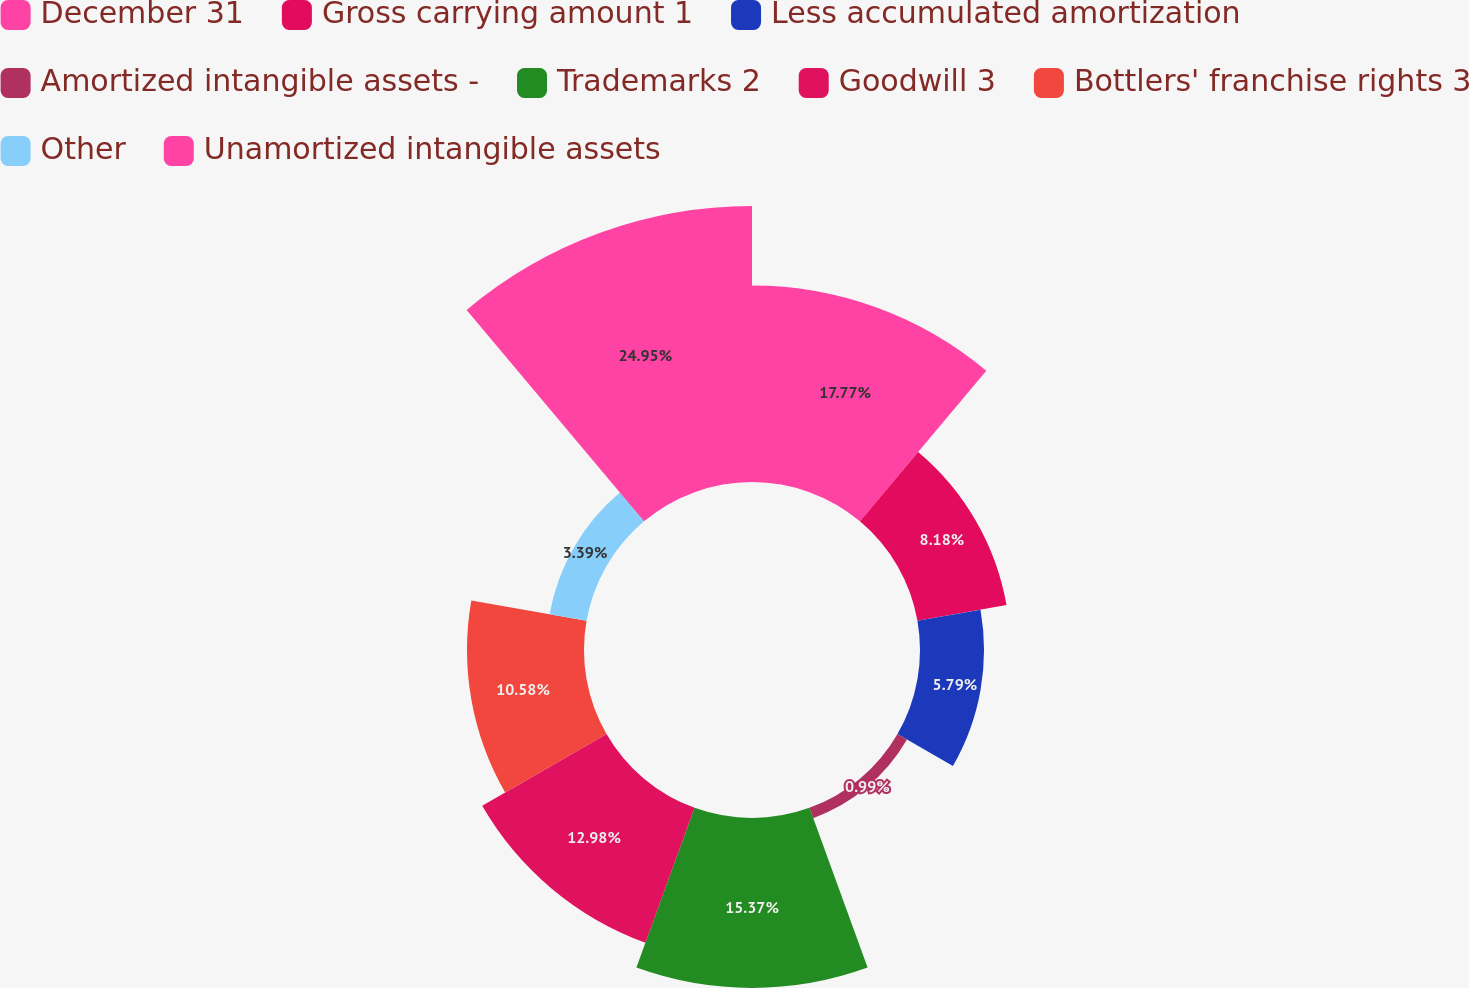<chart> <loc_0><loc_0><loc_500><loc_500><pie_chart><fcel>December 31<fcel>Gross carrying amount 1<fcel>Less accumulated amortization<fcel>Amortized intangible assets -<fcel>Trademarks 2<fcel>Goodwill 3<fcel>Bottlers' franchise rights 3<fcel>Other<fcel>Unamortized intangible assets<nl><fcel>17.77%<fcel>8.18%<fcel>5.79%<fcel>0.99%<fcel>15.37%<fcel>12.98%<fcel>10.58%<fcel>3.39%<fcel>24.96%<nl></chart> 